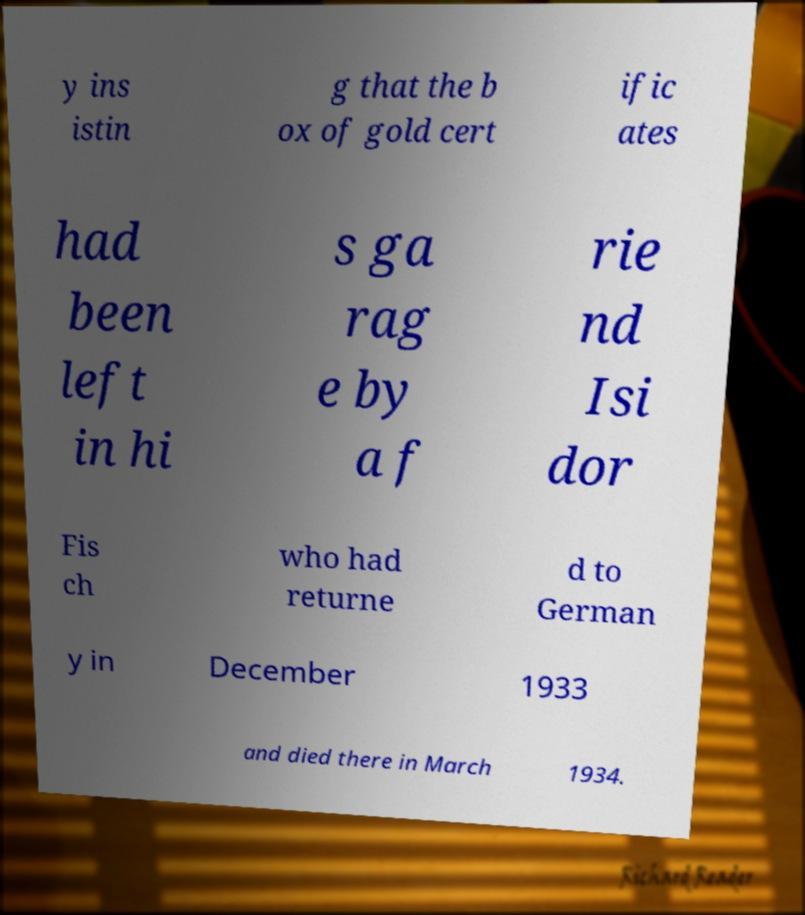Could you extract and type out the text from this image? y ins istin g that the b ox of gold cert ific ates had been left in hi s ga rag e by a f rie nd Isi dor Fis ch who had returne d to German y in December 1933 and died there in March 1934. 